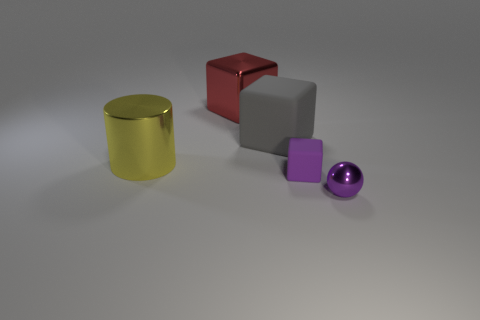How does the lighting in the image affect the perception of the objects? The lighting in the image is soft and diffused, creating gentle shadows and subtly highlighting the contours of each object. It affects the perception by emphasizing the material qualities and shapes, underscoring their three-dimensionality without casting harsh shadows that could obscure details. What time of day does the lighting resemble, if this were an outdoor setting? If we were to interpret the lighting as indicative of an outdoor time of day, it would resemble an overcast day where the sunlight is diffused through a layer of clouds, providing uniform illumination without any direct sunlight. 